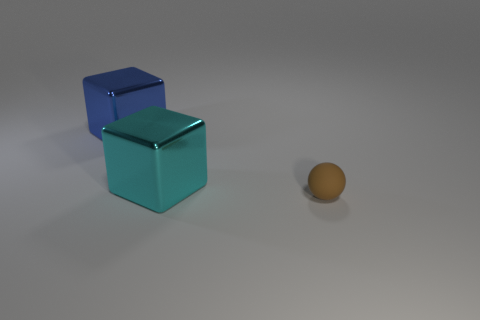Add 2 small matte objects. How many objects exist? 5 Subtract all cyan cubes. How many cubes are left? 1 Subtract all balls. How many objects are left? 2 Add 2 large brown rubber blocks. How many large brown rubber blocks exist? 2 Subtract 0 cyan cylinders. How many objects are left? 3 Subtract all cyan balls. Subtract all gray blocks. How many balls are left? 1 Subtract all green blocks. Subtract all large blue metallic cubes. How many objects are left? 2 Add 2 big cyan blocks. How many big cyan blocks are left? 3 